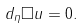<formula> <loc_0><loc_0><loc_500><loc_500>d _ { \eta } \Box u = 0 .</formula> 